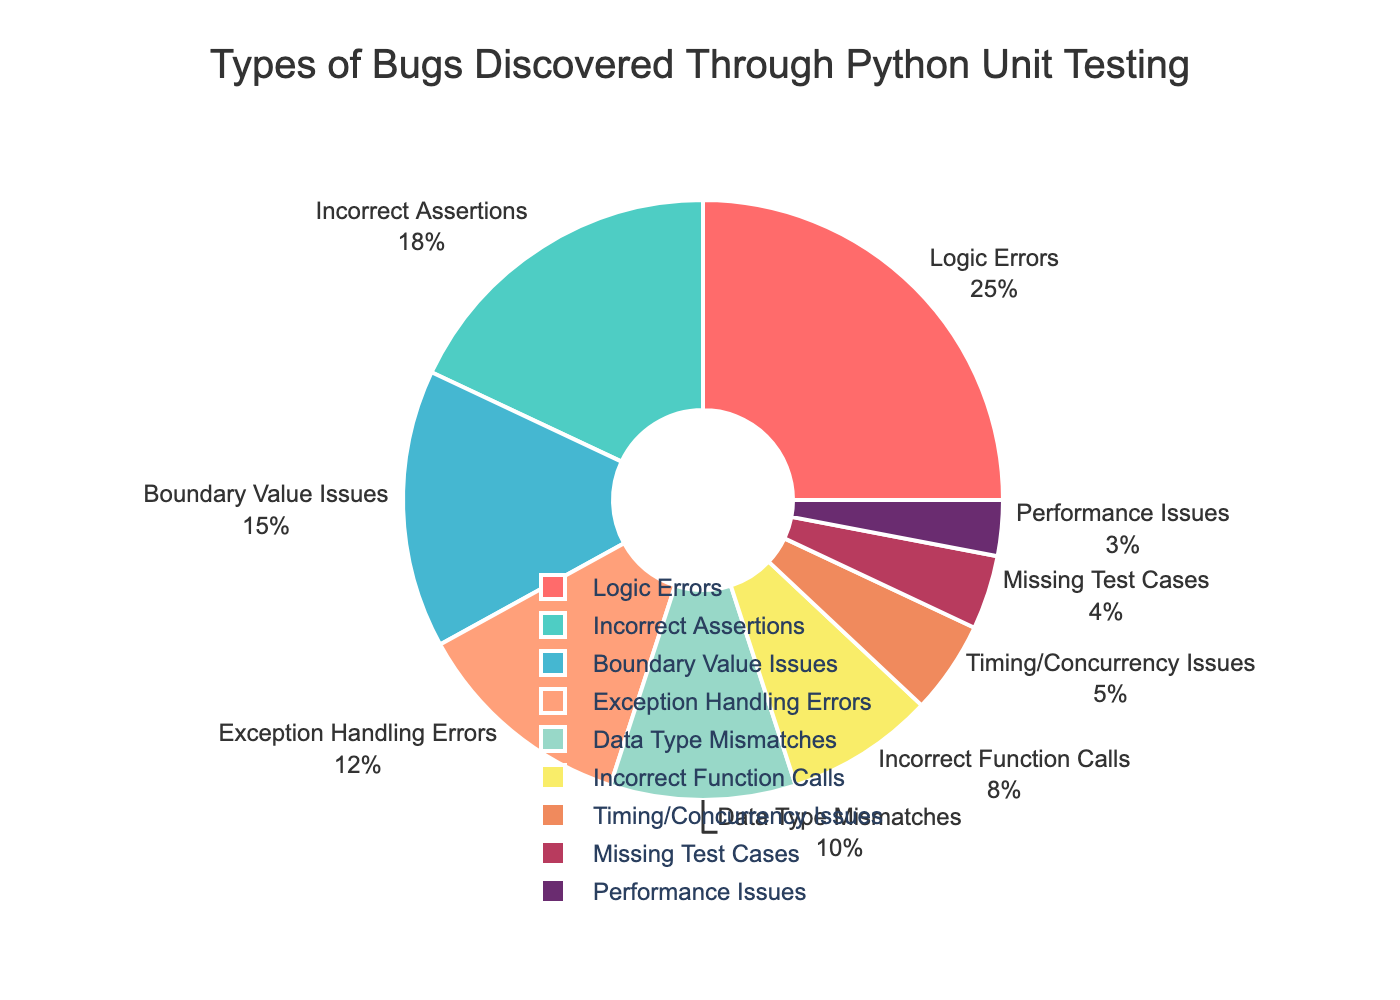What is the largest category of bugs discovered through Python unit testing? The largest category can be identified by looking at the slice with the highest percentage label on the pie chart. The largest category is "Logic Errors" with 25%.
Answer: Logic Errors Which category has the smallest percentage of bugs discovered? To identify the smallest category, we look at the slice with the lowest percentage. The smallest category is "Performance Issues" with 3%.
Answer: Performance Issues How much more prevalent are Logic Errors compared to Performance Issues? The percentage of Logic Errors is 25% and Performance Issues is 3%. Calculate the difference: 25% - 3% = 22%.
Answer: 22% What is the combined percentage of bugs in the categories "Boundary Value Issues" and "Exception Handling Errors"? Add the percentages of "Boundary Value Issues" (15%) and "Exception Handling Errors" (12%): 15% + 12% = 27%.
Answer: 27% Which categories constitute more than 10% of the total bugs discovered? Using the pie chart, identify and list the categories that have percentages more than 10%. These categories are "Logic Errors" (25%), "Incorrect Assertions" (18%), "Boundary Value Issues" (15%), and "Exception Handling Errors" (12%).
Answer: Logic Errors, Incorrect Assertions, Boundary Value Issues, Exception Handling Errors Are there more bugs related to "Incorrect Assertions" or "Data Type Mismatches"? Compare the percentages of "Incorrect Assertions" (18%) and "Data Type Mismatches" (10%). "Incorrect Assertions" have a higher percentage.
Answer: Incorrect Assertions What is the difference in percentage between "Incorrect Function Calls" and "Timing/Concurrency Issues"? Subtract the percentage of "Timing/Concurrency Issues" (5%) from "Incorrect Function Calls" (8%): 8% - 5% = 3%.
Answer: 3% How many categories have a percentage higher than 5%? Count all categories with a percentage greater than 5%. These categories are "Logic Errors", "Incorrect Assertions", "Boundary Value Issues", "Exception Handling Errors", "Data Type Mismatches", and "Incorrect Function Calls", totaling 6 categories.
Answer: 6 What percentage of the pie chart slices are shaded in green tones? Identify the slices with green tones in the pie chart. "Incorrect Assertions" (18%) and "Boundary Value Issues" (15%) are shades of green. Summing these gives 18% + 15% = 33%.
Answer: 33% 